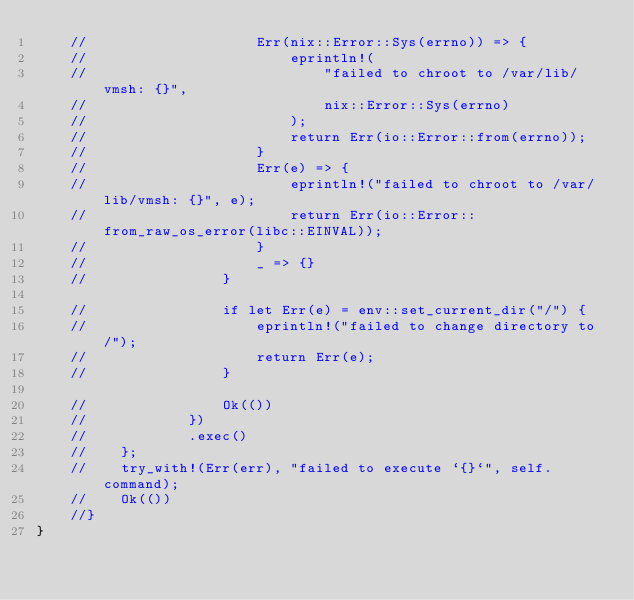<code> <loc_0><loc_0><loc_500><loc_500><_Rust_>    //                    Err(nix::Error::Sys(errno)) => {
    //                        eprintln!(
    //                            "failed to chroot to /var/lib/vmsh: {}",
    //                            nix::Error::Sys(errno)
    //                        );
    //                        return Err(io::Error::from(errno));
    //                    }
    //                    Err(e) => {
    //                        eprintln!("failed to chroot to /var/lib/vmsh: {}", e);
    //                        return Err(io::Error::from_raw_os_error(libc::EINVAL));
    //                    }
    //                    _ => {}
    //                }

    //                if let Err(e) = env::set_current_dir("/") {
    //                    eprintln!("failed to change directory to /");
    //                    return Err(e);
    //                }

    //                Ok(())
    //            })
    //            .exec()
    //    };
    //    try_with!(Err(err), "failed to execute `{}`", self.command);
    //    Ok(())
    //}
}
</code> 